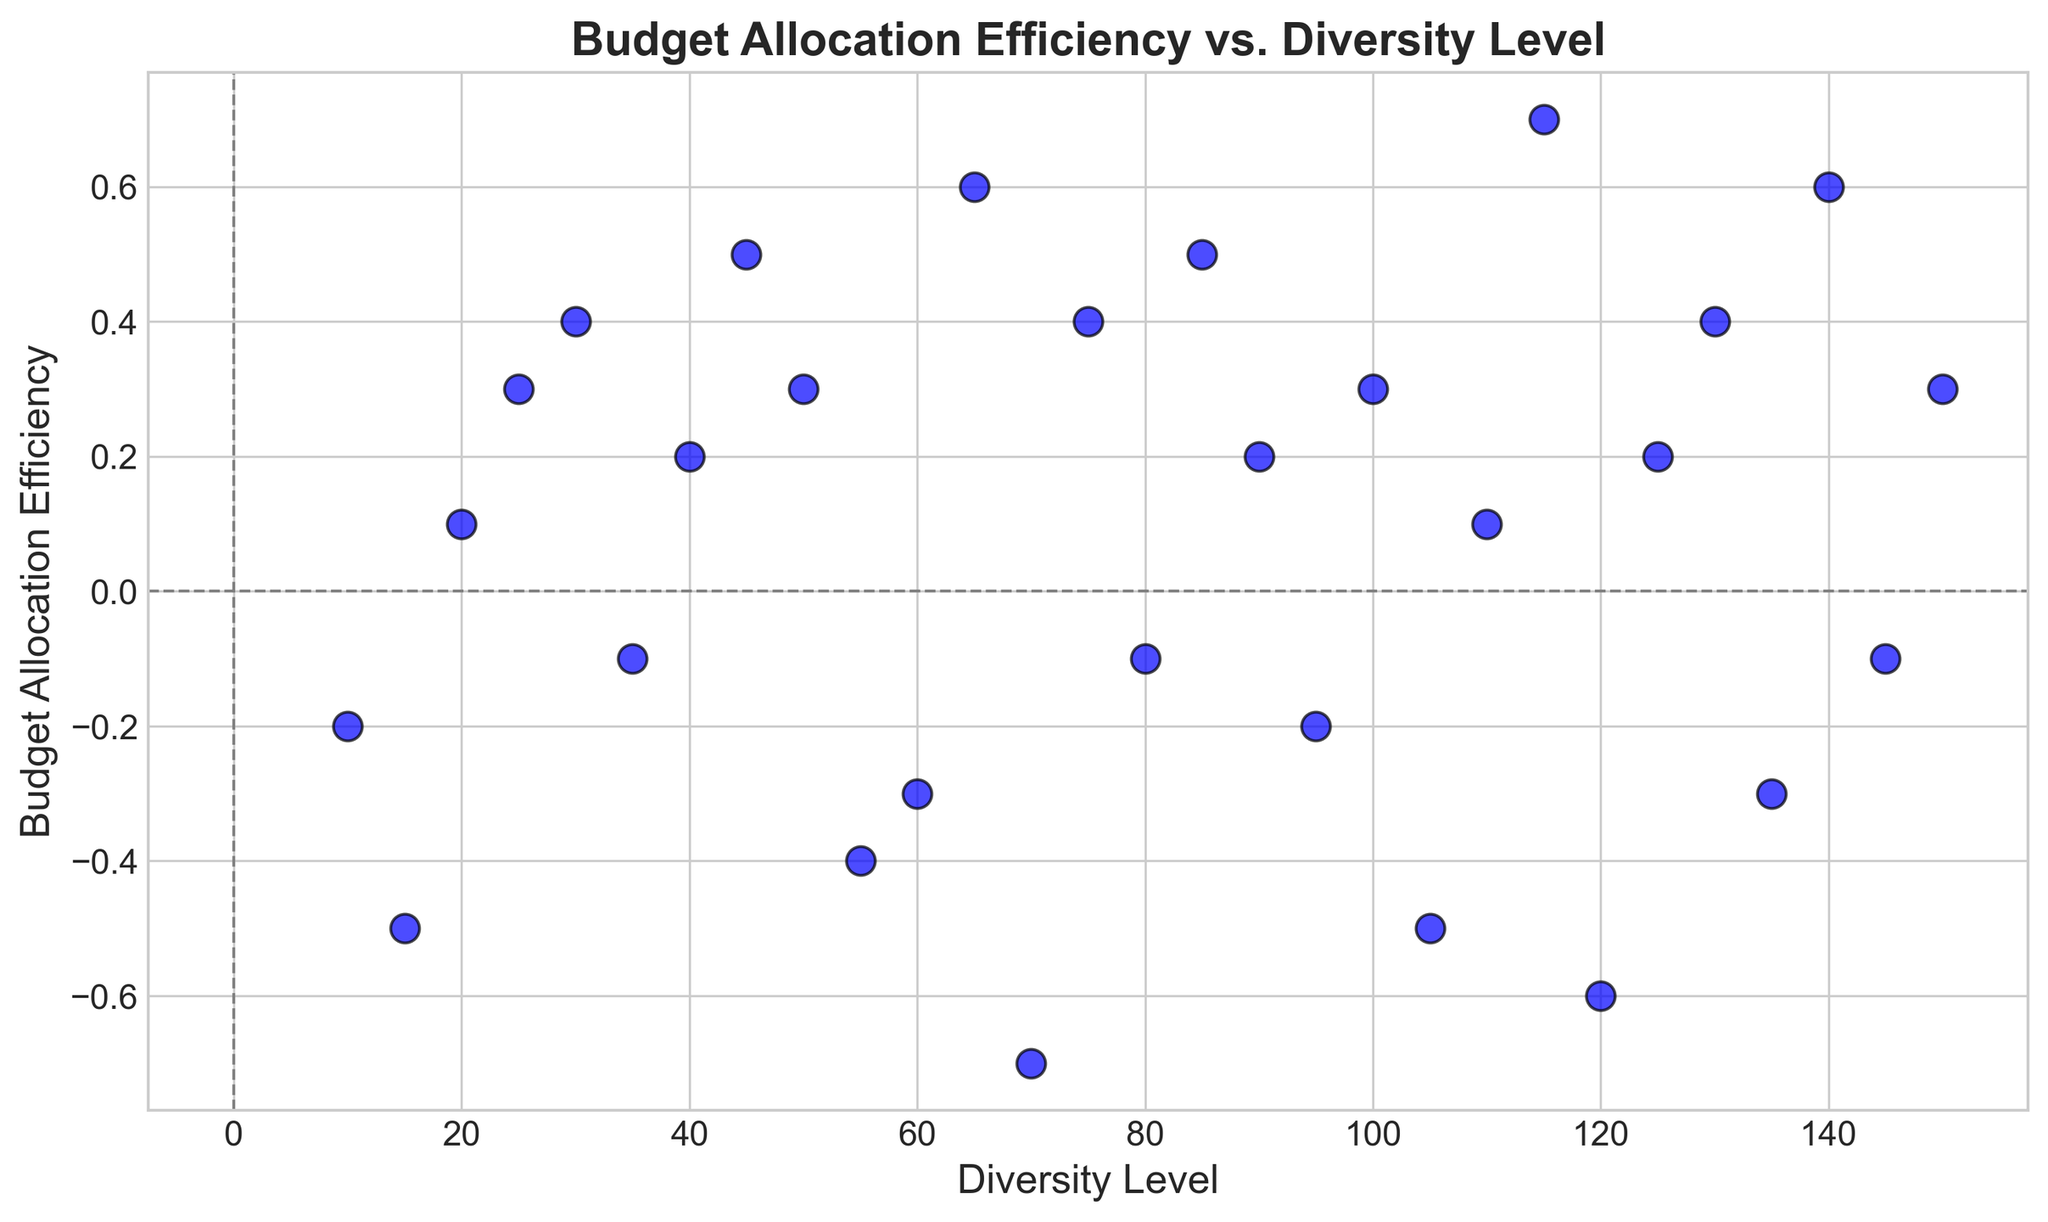What is the general trend in Budget Allocation Efficiency as the Diversity Level increases? To determine the general trend, observe the scatter plot for the overall direction of the data points. As Diversity Level increases from 10 to 150, there is a mix of positive and negative Budget Allocation Efficiency, but overall, there seems to be an upward trend in efficiency.
Answer: Increasing What is the Diversity Level where Budget Allocation Efficiency reaches its peak? Find the highest point on the scatter plot, which corresponds to the highest value on the y-axis (Budget Allocation Efficiency). The highest value is 0.7 at a Diversity Level of 115.
Answer: 115 How many data points are above the Budget Allocation Efficiency of 0.4? Count the number of points above the line y=0.4 on the scatter plot. There are 5 points above this threshold.
Answer: 5 Which Diversity Level has the lowest Budget Allocation Efficiency and what is the value? Find the point lowest on the y-axis, signifying the lowest Budget Allocation Efficiency. The lowest value is -0.7 at a Diversity Level of 70.
Answer: 70 and -0.7 Do more data points lie above or below the Budget Allocation Efficiency of 0? Locate the horizontal line y=0 on the plot and count the points above and below this line. There are more points above 0 (16) than below 0 (14).
Answer: Above What is the average Budget Allocation Efficiency for Diversity Levels between 50 and 100 inclusive? Identify all data points between Diversity Levels 50 and 100. The values are -0.4, -0.3, 0.6, -0.7, 0.4, -0.1, 0.5, and 0.2. Sum these values (-0.4 + -0.3 + 0.6 + -0.7 + 0.4 + -0.1 + 0.5 + 0.2 = 0.2) and divide by the number of values (8), yielding 0.2/8 = 0.025.
Answer: 0.025 Which Diversity Level between 125 and 150 shows the highest Budget Allocation Efficiency? Consider the points between 125 and 150. Compare their efficiencies. The highest value is 0.6 at Diversity Level 140.
Answer: 140 What is the range of Budget Allocation Efficiency values for data points with above-median Diversity Levels? First, find the median Diversity Level (median of 10, 15, ..., 150 is 80). Consider points above 80 (85, 90, ..., 150). The values are 0.5, 0.2, -0.2, 0.3, -0.5, 0.1, 0.7, -0.6, 0.2, 0.4, -0.3, 0.6, -0.1, 0.3. The range is from -0.6 to 0.7.
Answer: -0.6 to 0.7 